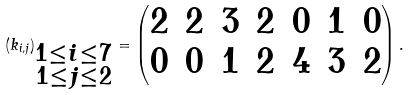<formula> <loc_0><loc_0><loc_500><loc_500>( k _ { i , j } ) _ { \substack { 1 \leq i \leq 7 \\ 1 \leq j \leq 2 } } = \begin{pmatrix} 2 & 2 & 3 & 2 & 0 & 1 & 0 \\ 0 & 0 & 1 & 2 & 4 & 3 & 2 \end{pmatrix} .</formula> 